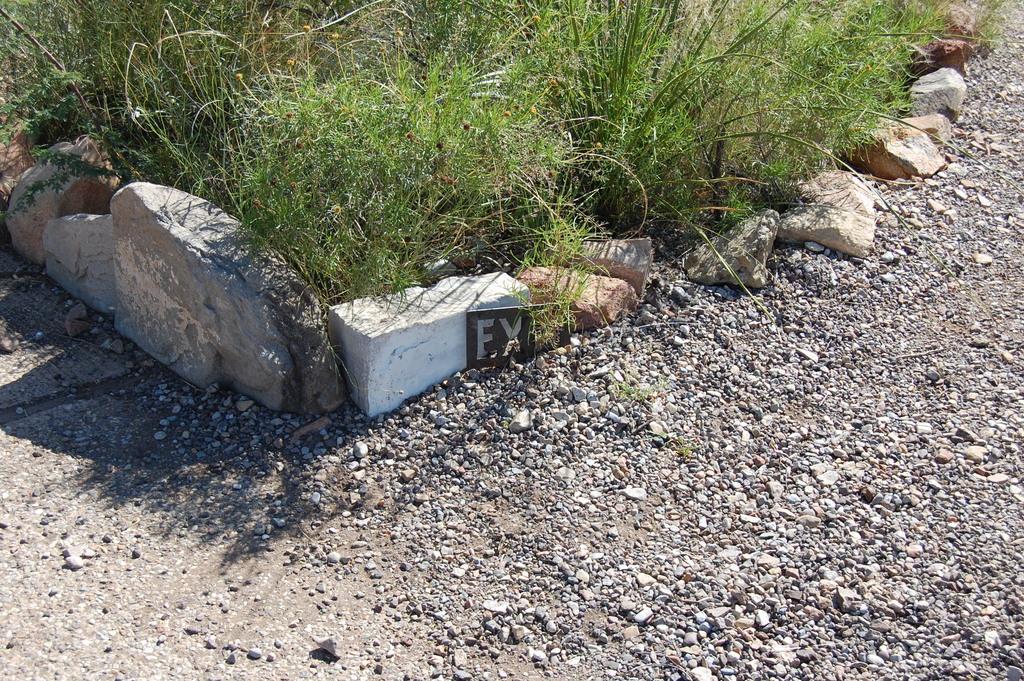Can you describe this image briefly? In this image I can see concretes, stone fence and grass. This image is taken may be during a day. 